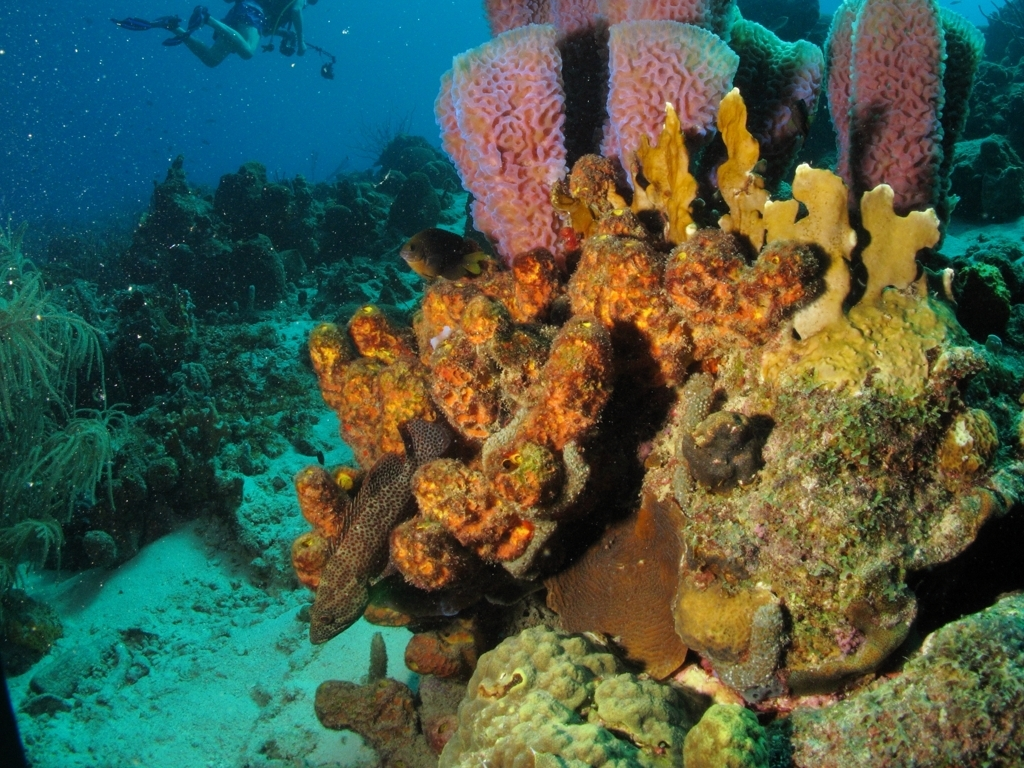What does an image like this tell us about the health of the ocean? This image is quite telling of ocean health. Vibrant and diverse coral ecosystems like the one shown are often indicators of a thriving marine environment. Corals are sensitive to changes in water temperature, acidity, and clarity, so their robust presence suggests good water quality and stability in this area. Healthy reefs support a wide variety of species and are crucial to the overall well-being of oceanic ecosystems. 